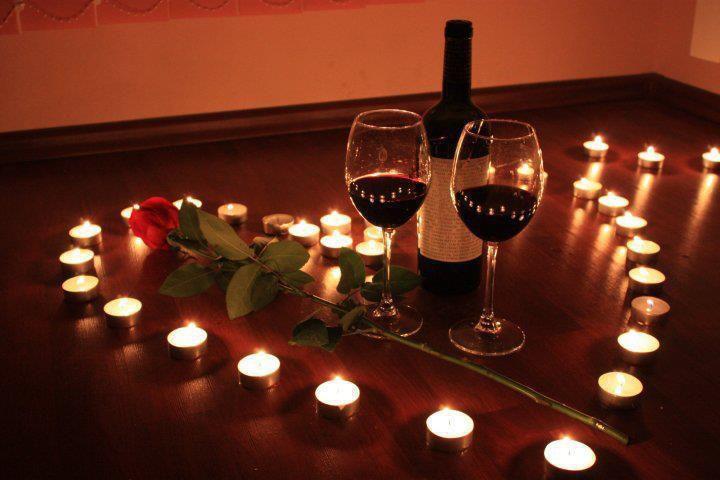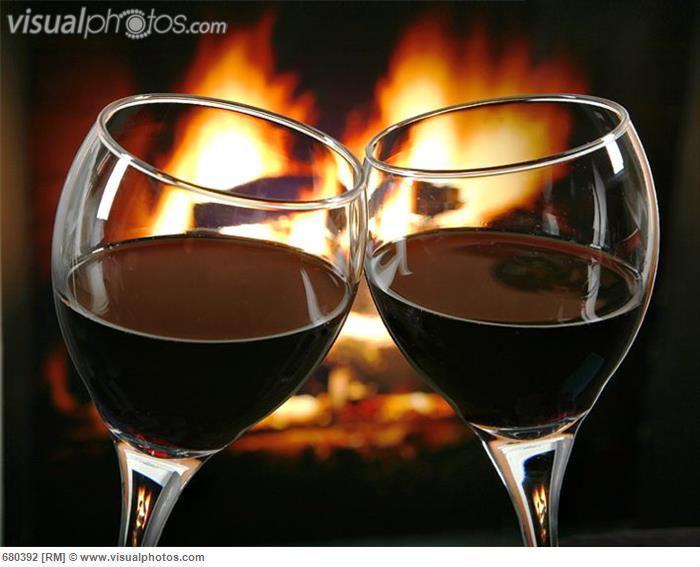The first image is the image on the left, the second image is the image on the right. For the images displayed, is the sentence "An image shows wisps of white smoke around two glasses of dark red wine, standing near candles." factually correct? Answer yes or no. No. 